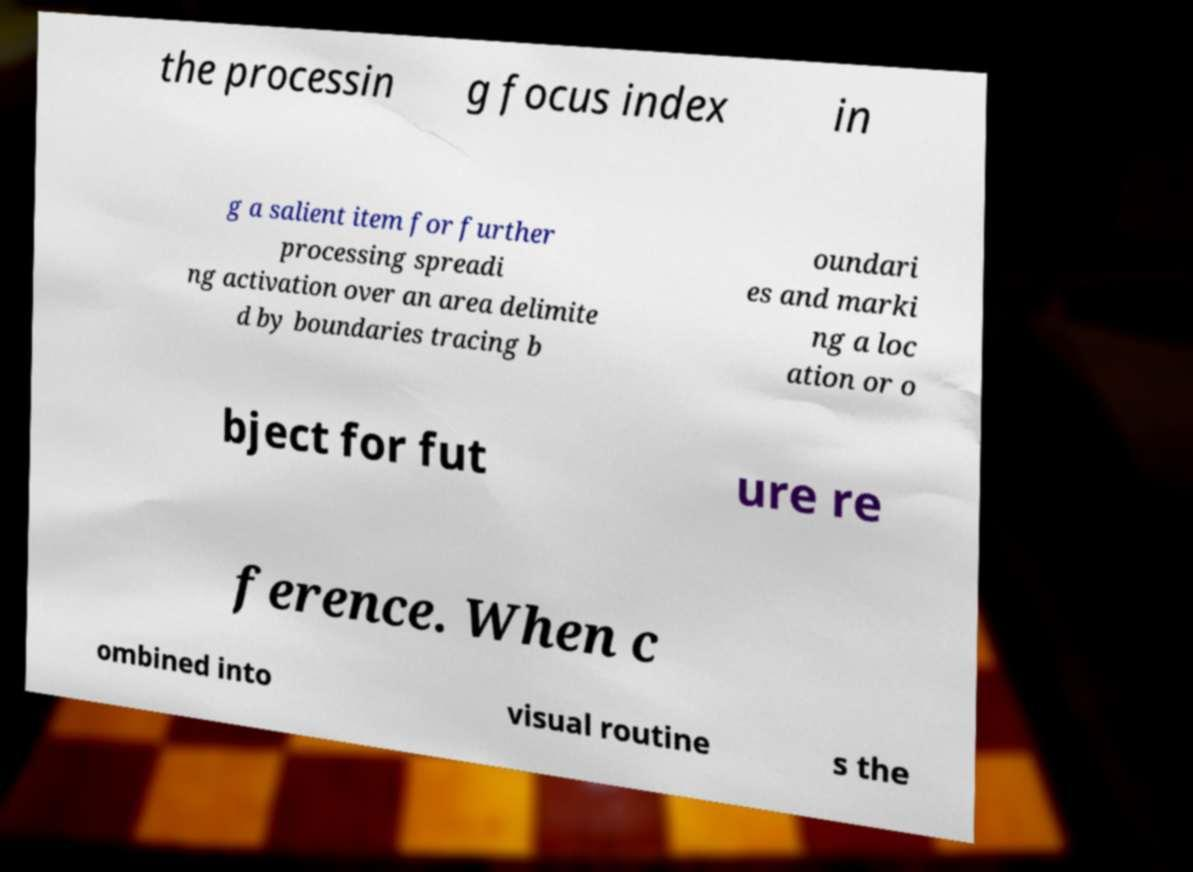For documentation purposes, I need the text within this image transcribed. Could you provide that? the processin g focus index in g a salient item for further processing spreadi ng activation over an area delimite d by boundaries tracing b oundari es and marki ng a loc ation or o bject for fut ure re ference. When c ombined into visual routine s the 